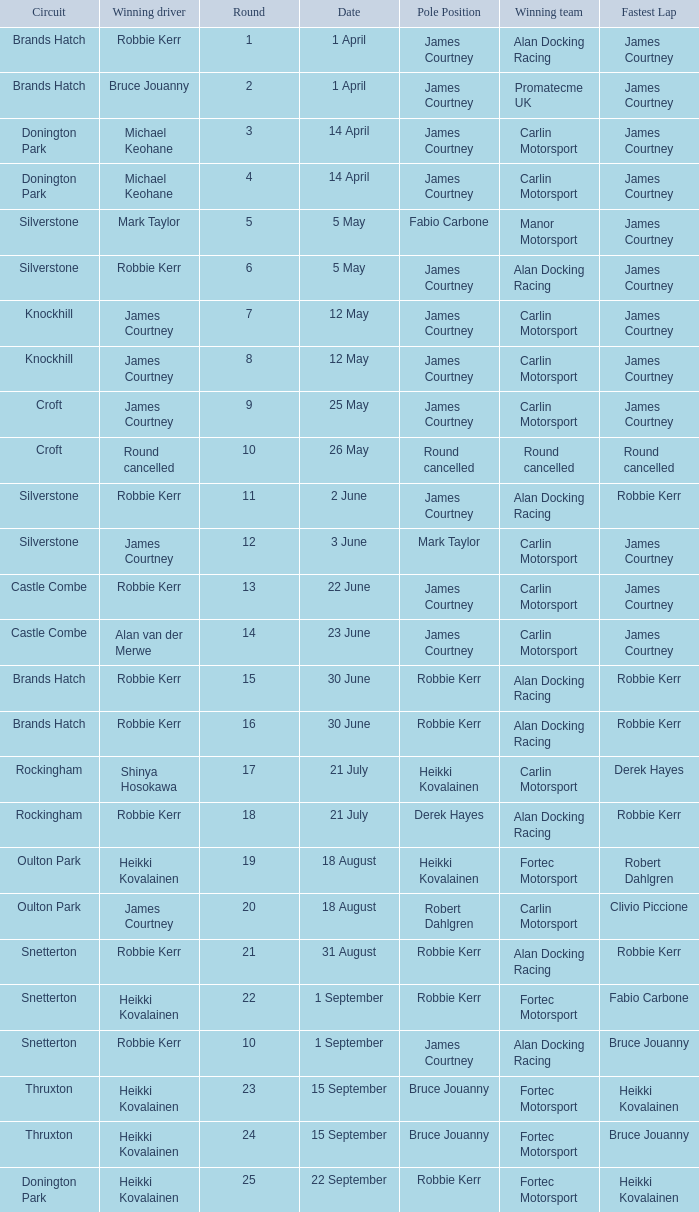What is every pole position for the Castle Combe circuit and Robbie Kerr is the winning driver? James Courtney. 